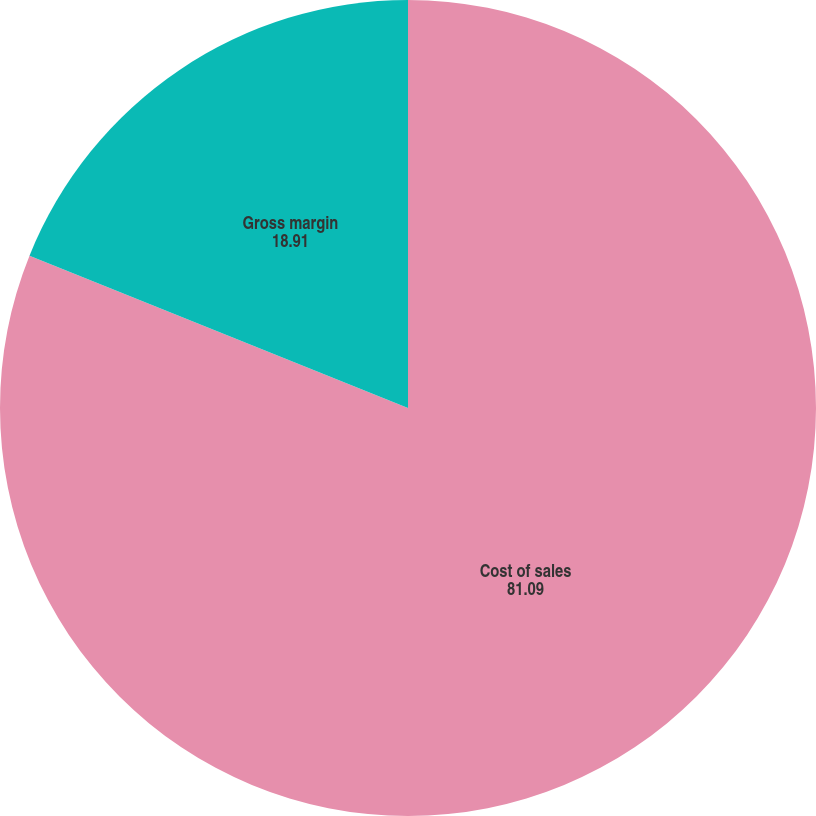Convert chart. <chart><loc_0><loc_0><loc_500><loc_500><pie_chart><fcel>Cost of sales<fcel>Gross margin<nl><fcel>81.09%<fcel>18.91%<nl></chart> 